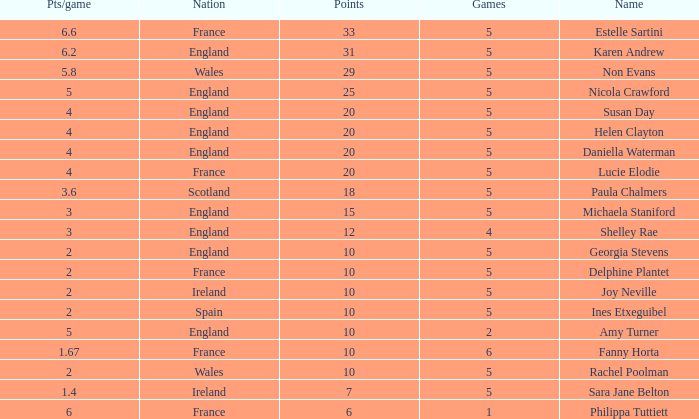Can you tell me the average Points that has a Pts/game larger than 4, and the Nation of england, and the Games smaller than 5? 10.0. 